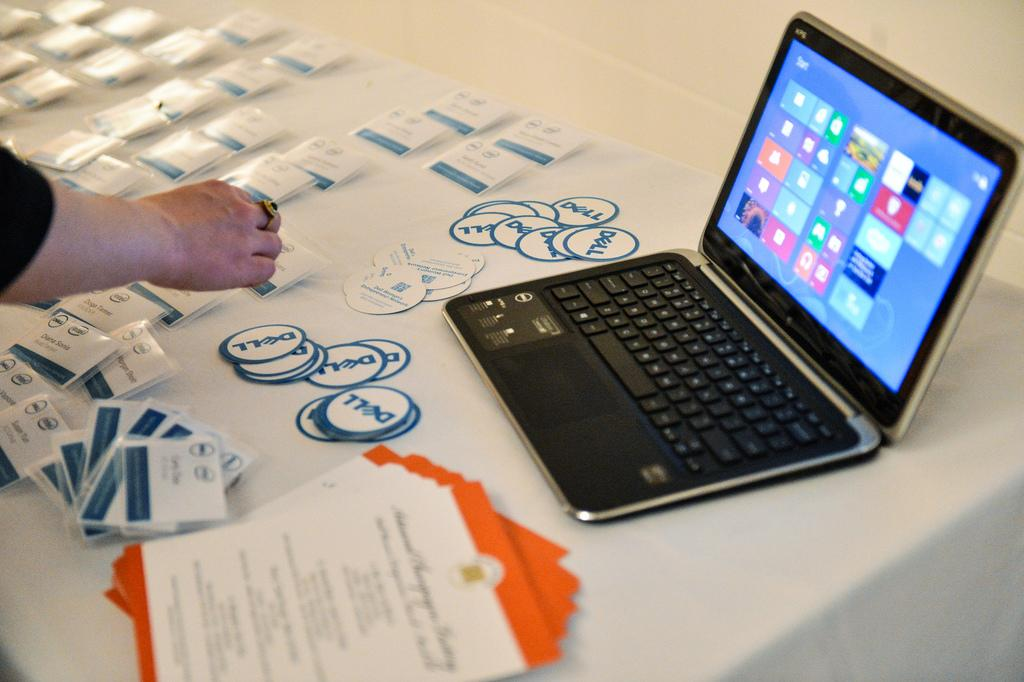What is on the table in the image? There is a laptop on a table in the image. What can be seen on the laptop? The laptop has stickers on it, and there are pamphlets on top of it. Who is present in the image? There is a person holding stickers on the left side of the image. What type of cracker is being eaten by the person on the coast in the image? There is no person eating a cracker on the coast in the image; the image features a laptop on a table and a person holding stickers. 